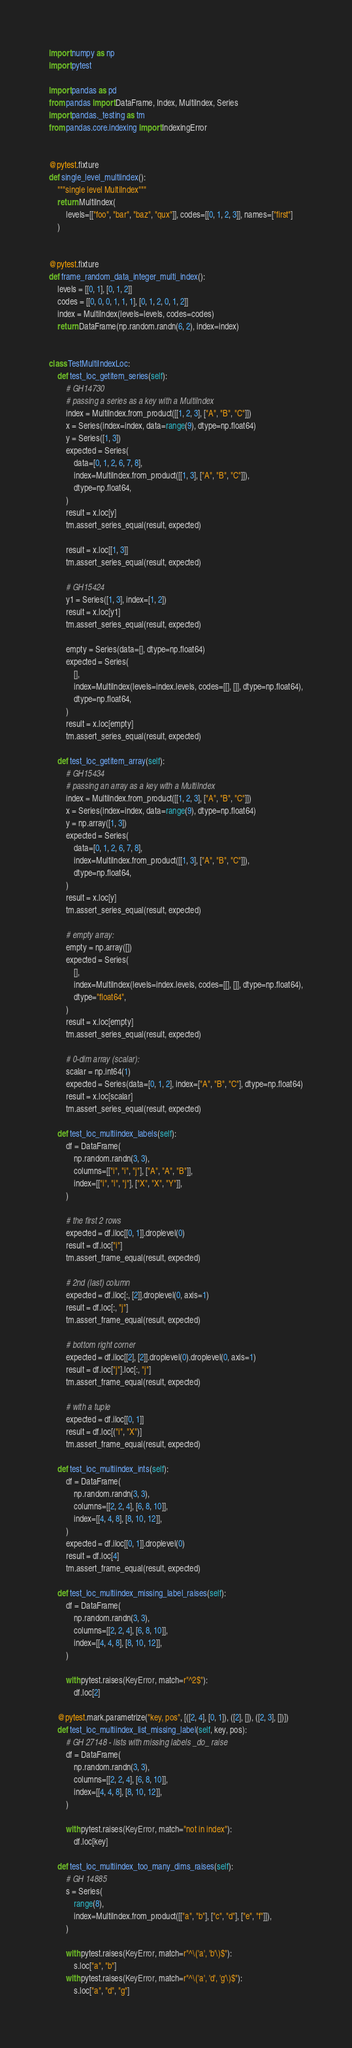Convert code to text. <code><loc_0><loc_0><loc_500><loc_500><_Python_>import numpy as np
import pytest

import pandas as pd
from pandas import DataFrame, Index, MultiIndex, Series
import pandas._testing as tm
from pandas.core.indexing import IndexingError


@pytest.fixture
def single_level_multiindex():
    """single level MultiIndex"""
    return MultiIndex(
        levels=[["foo", "bar", "baz", "qux"]], codes=[[0, 1, 2, 3]], names=["first"]
    )


@pytest.fixture
def frame_random_data_integer_multi_index():
    levels = [[0, 1], [0, 1, 2]]
    codes = [[0, 0, 0, 1, 1, 1], [0, 1, 2, 0, 1, 2]]
    index = MultiIndex(levels=levels, codes=codes)
    return DataFrame(np.random.randn(6, 2), index=index)


class TestMultiIndexLoc:
    def test_loc_getitem_series(self):
        # GH14730
        # passing a series as a key with a MultiIndex
        index = MultiIndex.from_product([[1, 2, 3], ["A", "B", "C"]])
        x = Series(index=index, data=range(9), dtype=np.float64)
        y = Series([1, 3])
        expected = Series(
            data=[0, 1, 2, 6, 7, 8],
            index=MultiIndex.from_product([[1, 3], ["A", "B", "C"]]),
            dtype=np.float64,
        )
        result = x.loc[y]
        tm.assert_series_equal(result, expected)

        result = x.loc[[1, 3]]
        tm.assert_series_equal(result, expected)

        # GH15424
        y1 = Series([1, 3], index=[1, 2])
        result = x.loc[y1]
        tm.assert_series_equal(result, expected)

        empty = Series(data=[], dtype=np.float64)
        expected = Series(
            [],
            index=MultiIndex(levels=index.levels, codes=[[], []], dtype=np.float64),
            dtype=np.float64,
        )
        result = x.loc[empty]
        tm.assert_series_equal(result, expected)

    def test_loc_getitem_array(self):
        # GH15434
        # passing an array as a key with a MultiIndex
        index = MultiIndex.from_product([[1, 2, 3], ["A", "B", "C"]])
        x = Series(index=index, data=range(9), dtype=np.float64)
        y = np.array([1, 3])
        expected = Series(
            data=[0, 1, 2, 6, 7, 8],
            index=MultiIndex.from_product([[1, 3], ["A", "B", "C"]]),
            dtype=np.float64,
        )
        result = x.loc[y]
        tm.assert_series_equal(result, expected)

        # empty array:
        empty = np.array([])
        expected = Series(
            [],
            index=MultiIndex(levels=index.levels, codes=[[], []], dtype=np.float64),
            dtype="float64",
        )
        result = x.loc[empty]
        tm.assert_series_equal(result, expected)

        # 0-dim array (scalar):
        scalar = np.int64(1)
        expected = Series(data=[0, 1, 2], index=["A", "B", "C"], dtype=np.float64)
        result = x.loc[scalar]
        tm.assert_series_equal(result, expected)

    def test_loc_multiindex_labels(self):
        df = DataFrame(
            np.random.randn(3, 3),
            columns=[["i", "i", "j"], ["A", "A", "B"]],
            index=[["i", "i", "j"], ["X", "X", "Y"]],
        )

        # the first 2 rows
        expected = df.iloc[[0, 1]].droplevel(0)
        result = df.loc["i"]
        tm.assert_frame_equal(result, expected)

        # 2nd (last) column
        expected = df.iloc[:, [2]].droplevel(0, axis=1)
        result = df.loc[:, "j"]
        tm.assert_frame_equal(result, expected)

        # bottom right corner
        expected = df.iloc[[2], [2]].droplevel(0).droplevel(0, axis=1)
        result = df.loc["j"].loc[:, "j"]
        tm.assert_frame_equal(result, expected)

        # with a tuple
        expected = df.iloc[[0, 1]]
        result = df.loc[("i", "X")]
        tm.assert_frame_equal(result, expected)

    def test_loc_multiindex_ints(self):
        df = DataFrame(
            np.random.randn(3, 3),
            columns=[[2, 2, 4], [6, 8, 10]],
            index=[[4, 4, 8], [8, 10, 12]],
        )
        expected = df.iloc[[0, 1]].droplevel(0)
        result = df.loc[4]
        tm.assert_frame_equal(result, expected)

    def test_loc_multiindex_missing_label_raises(self):
        df = DataFrame(
            np.random.randn(3, 3),
            columns=[[2, 2, 4], [6, 8, 10]],
            index=[[4, 4, 8], [8, 10, 12]],
        )

        with pytest.raises(KeyError, match=r"^2$"):
            df.loc[2]

    @pytest.mark.parametrize("key, pos", [([2, 4], [0, 1]), ([2], []), ([2, 3], [])])
    def test_loc_multiindex_list_missing_label(self, key, pos):
        # GH 27148 - lists with missing labels _do_ raise
        df = DataFrame(
            np.random.randn(3, 3),
            columns=[[2, 2, 4], [6, 8, 10]],
            index=[[4, 4, 8], [8, 10, 12]],
        )

        with pytest.raises(KeyError, match="not in index"):
            df.loc[key]

    def test_loc_multiindex_too_many_dims_raises(self):
        # GH 14885
        s = Series(
            range(8),
            index=MultiIndex.from_product([["a", "b"], ["c", "d"], ["e", "f"]]),
        )

        with pytest.raises(KeyError, match=r"^\('a', 'b'\)$"):
            s.loc["a", "b"]
        with pytest.raises(KeyError, match=r"^\('a', 'd', 'g'\)$"):
            s.loc["a", "d", "g"]</code> 